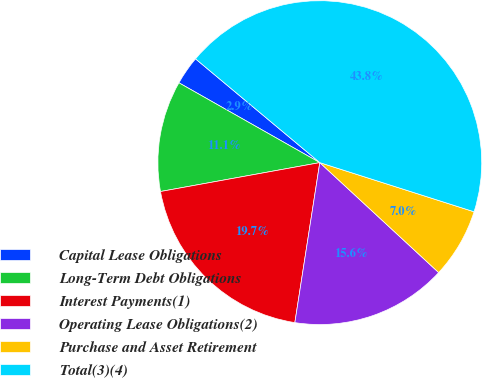Convert chart to OTSL. <chart><loc_0><loc_0><loc_500><loc_500><pie_chart><fcel>Capital Lease Obligations<fcel>Long-Term Debt Obligations<fcel>Interest Payments(1)<fcel>Operating Lease Obligations(2)<fcel>Purchase and Asset Retirement<fcel>Total(3)(4)<nl><fcel>2.87%<fcel>11.06%<fcel>19.68%<fcel>15.58%<fcel>6.97%<fcel>43.83%<nl></chart> 